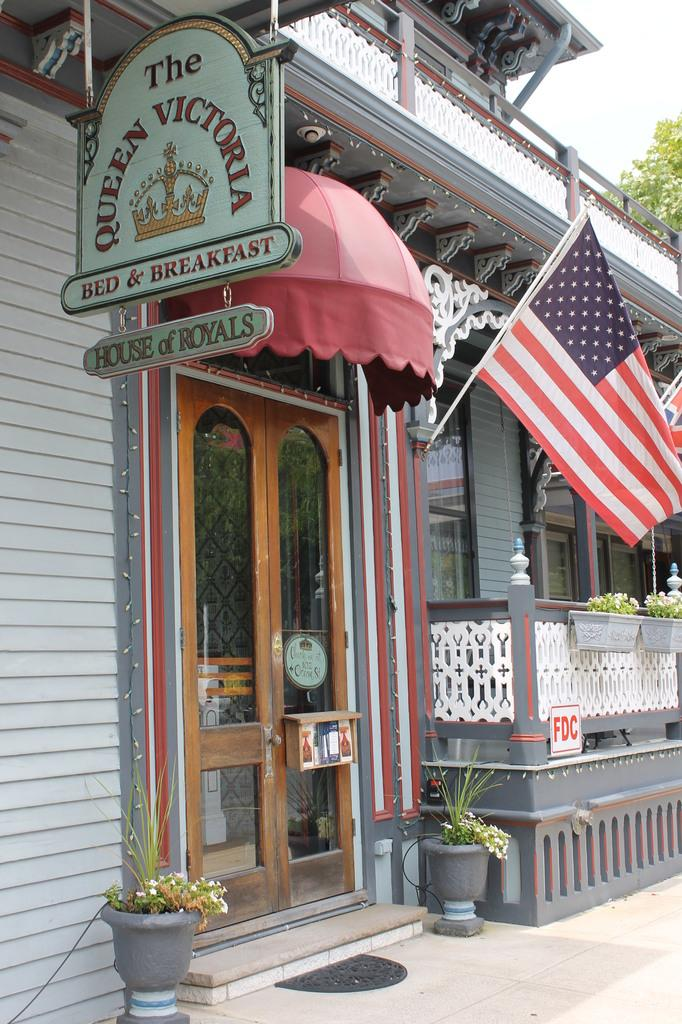<image>
Describe the image concisely. A grey building with American flags and a sign that says The Queen Victoria. 